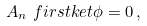<formula> <loc_0><loc_0><loc_500><loc_500>A _ { n } \ f i r s t k e t { \phi } = 0 \, ,</formula> 